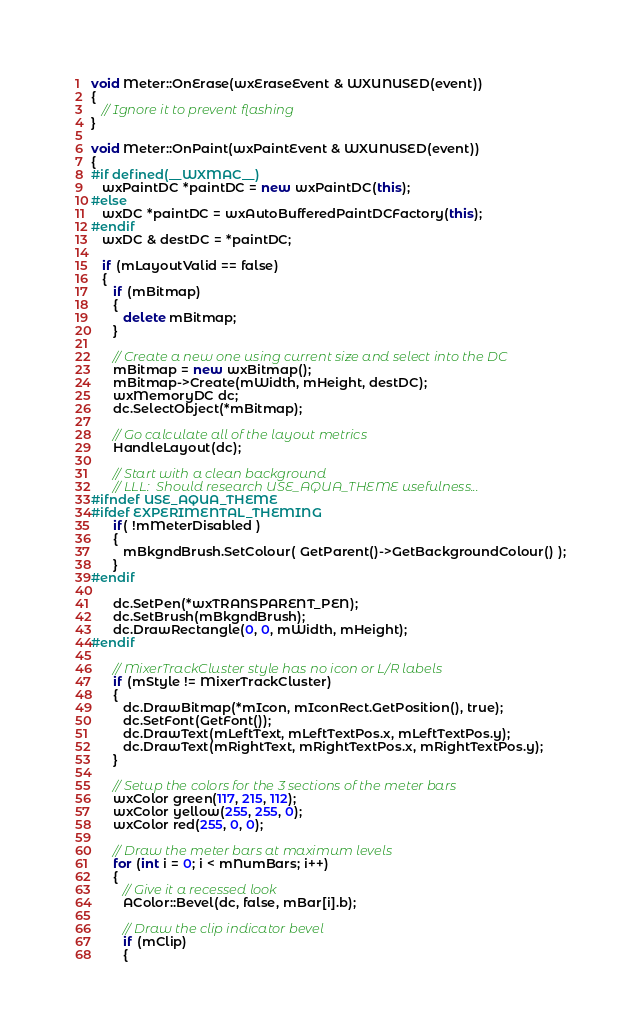<code> <loc_0><loc_0><loc_500><loc_500><_C++_>void Meter::OnErase(wxEraseEvent & WXUNUSED(event))
{
   // Ignore it to prevent flashing
}

void Meter::OnPaint(wxPaintEvent & WXUNUSED(event))
{
#if defined(__WXMAC__)
   wxPaintDC *paintDC = new wxPaintDC(this);
#else
   wxDC *paintDC = wxAutoBufferedPaintDCFactory(this);
#endif
   wxDC & destDC = *paintDC;

   if (mLayoutValid == false)
   {
      if (mBitmap)
      {
         delete mBitmap;
      }
   
      // Create a new one using current size and select into the DC
      mBitmap = new wxBitmap();
      mBitmap->Create(mWidth, mHeight, destDC);
      wxMemoryDC dc;
      dc.SelectObject(*mBitmap);

      // Go calculate all of the layout metrics
      HandleLayout(dc);
   
      // Start with a clean background
      // LLL:  Should research USE_AQUA_THEME usefulness...
#ifndef USE_AQUA_THEME
#ifdef EXPERIMENTAL_THEMING
      if( !mMeterDisabled )
      {
         mBkgndBrush.SetColour( GetParent()->GetBackgroundColour() );
      }
#endif
   
      dc.SetPen(*wxTRANSPARENT_PEN);
      dc.SetBrush(mBkgndBrush);
      dc.DrawRectangle(0, 0, mWidth, mHeight);
#endif

      // MixerTrackCluster style has no icon or L/R labels
      if (mStyle != MixerTrackCluster)
      {
         dc.DrawBitmap(*mIcon, mIconRect.GetPosition(), true);
         dc.SetFont(GetFont());
         dc.DrawText(mLeftText, mLeftTextPos.x, mLeftTextPos.y);
         dc.DrawText(mRightText, mRightTextPos.x, mRightTextPos.y);
      }
   
      // Setup the colors for the 3 sections of the meter bars
      wxColor green(117, 215, 112);
      wxColor yellow(255, 255, 0);
      wxColor red(255, 0, 0);
   
      // Draw the meter bars at maximum levels
      for (int i = 0; i < mNumBars; i++)
      {
         // Give it a recessed look
         AColor::Bevel(dc, false, mBar[i].b);
   
         // Draw the clip indicator bevel
         if (mClip)
         {</code> 